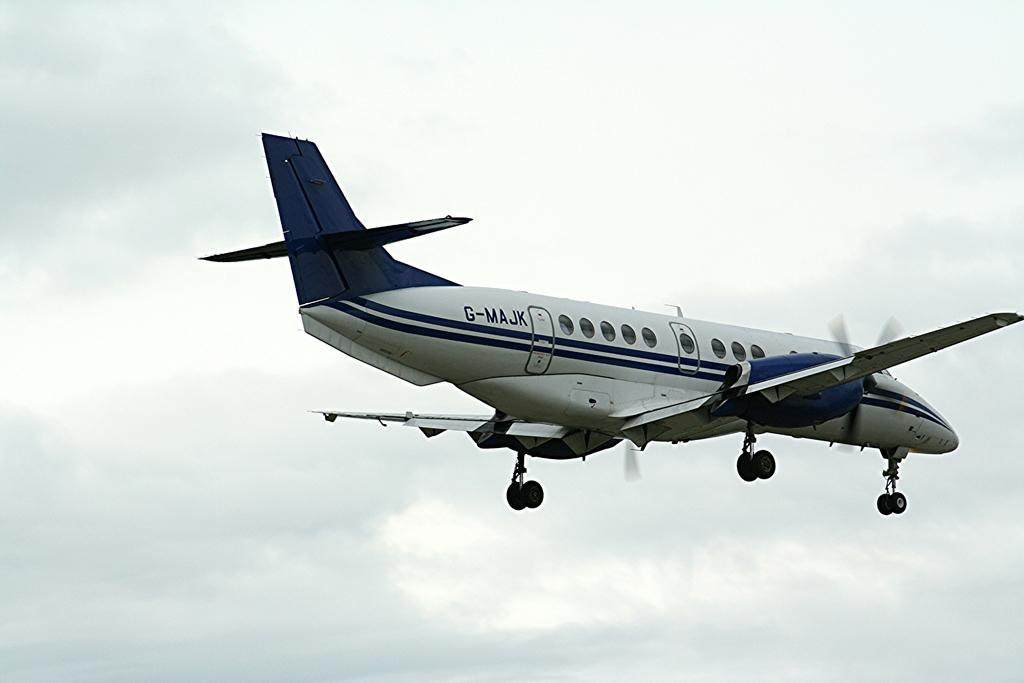<image>
Offer a succinct explanation of the picture presented. a small white and blue airplane with G-MAJK on its side 